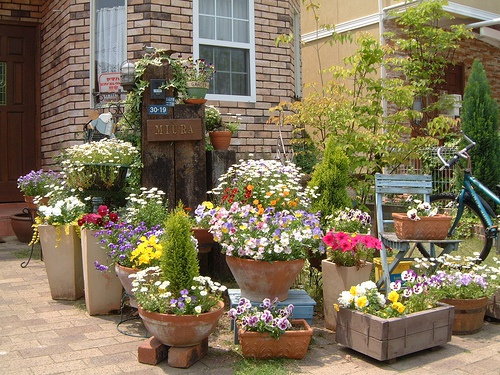Describe the objects in this image and their specific colors. I can see potted plant in maroon, olive, white, and gray tones, potted plant in maroon, gray, and olive tones, potted plant in maroon, olive, gray, and black tones, bicycle in maroon, black, olive, gray, and darkgreen tones, and chair in maroon, darkgray, gray, darkgreen, and black tones in this image. 